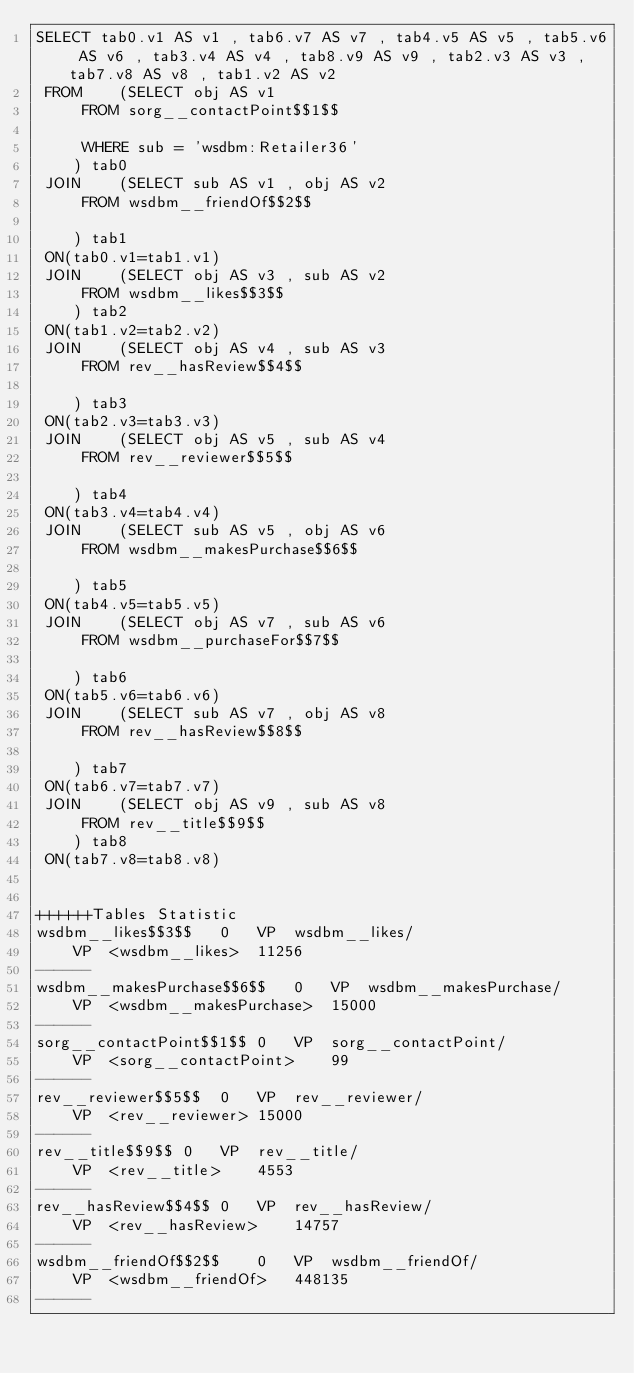<code> <loc_0><loc_0><loc_500><loc_500><_SQL_>SELECT tab0.v1 AS v1 , tab6.v7 AS v7 , tab4.v5 AS v5 , tab5.v6 AS v6 , tab3.v4 AS v4 , tab8.v9 AS v9 , tab2.v3 AS v3 , tab7.v8 AS v8 , tab1.v2 AS v2 
 FROM    (SELECT obj AS v1 
	 FROM sorg__contactPoint$$1$$
	 
	 WHERE sub = 'wsdbm:Retailer36'
	) tab0
 JOIN    (SELECT sub AS v1 , obj AS v2 
	 FROM wsdbm__friendOf$$2$$
	
	) tab1
 ON(tab0.v1=tab1.v1)
 JOIN    (SELECT obj AS v3 , sub AS v2 
	 FROM wsdbm__likes$$3$$
	) tab2
 ON(tab1.v2=tab2.v2)
 JOIN    (SELECT obj AS v4 , sub AS v3 
	 FROM rev__hasReview$$4$$
	
	) tab3
 ON(tab2.v3=tab3.v3)
 JOIN    (SELECT obj AS v5 , sub AS v4 
	 FROM rev__reviewer$$5$$
	
	) tab4
 ON(tab3.v4=tab4.v4)
 JOIN    (SELECT sub AS v5 , obj AS v6 
	 FROM wsdbm__makesPurchase$$6$$
	
	) tab5
 ON(tab4.v5=tab5.v5)
 JOIN    (SELECT obj AS v7 , sub AS v6 
	 FROM wsdbm__purchaseFor$$7$$
	
	) tab6
 ON(tab5.v6=tab6.v6)
 JOIN    (SELECT sub AS v7 , obj AS v8 
	 FROM rev__hasReview$$8$$
	
	) tab7
 ON(tab6.v7=tab7.v7)
 JOIN    (SELECT obj AS v9 , sub AS v8 
	 FROM rev__title$$9$$
	) tab8
 ON(tab7.v8=tab8.v8)


++++++Tables Statistic
wsdbm__likes$$3$$	0	VP	wsdbm__likes/
	VP	<wsdbm__likes>	11256
------
wsdbm__makesPurchase$$6$$	0	VP	wsdbm__makesPurchase/
	VP	<wsdbm__makesPurchase>	15000
------
sorg__contactPoint$$1$$	0	VP	sorg__contactPoint/
	VP	<sorg__contactPoint>	99
------
rev__reviewer$$5$$	0	VP	rev__reviewer/
	VP	<rev__reviewer>	15000
------
rev__title$$9$$	0	VP	rev__title/
	VP	<rev__title>	4553
------
rev__hasReview$$4$$	0	VP	rev__hasReview/
	VP	<rev__hasReview>	14757
------
wsdbm__friendOf$$2$$	0	VP	wsdbm__friendOf/
	VP	<wsdbm__friendOf>	448135
------</code> 